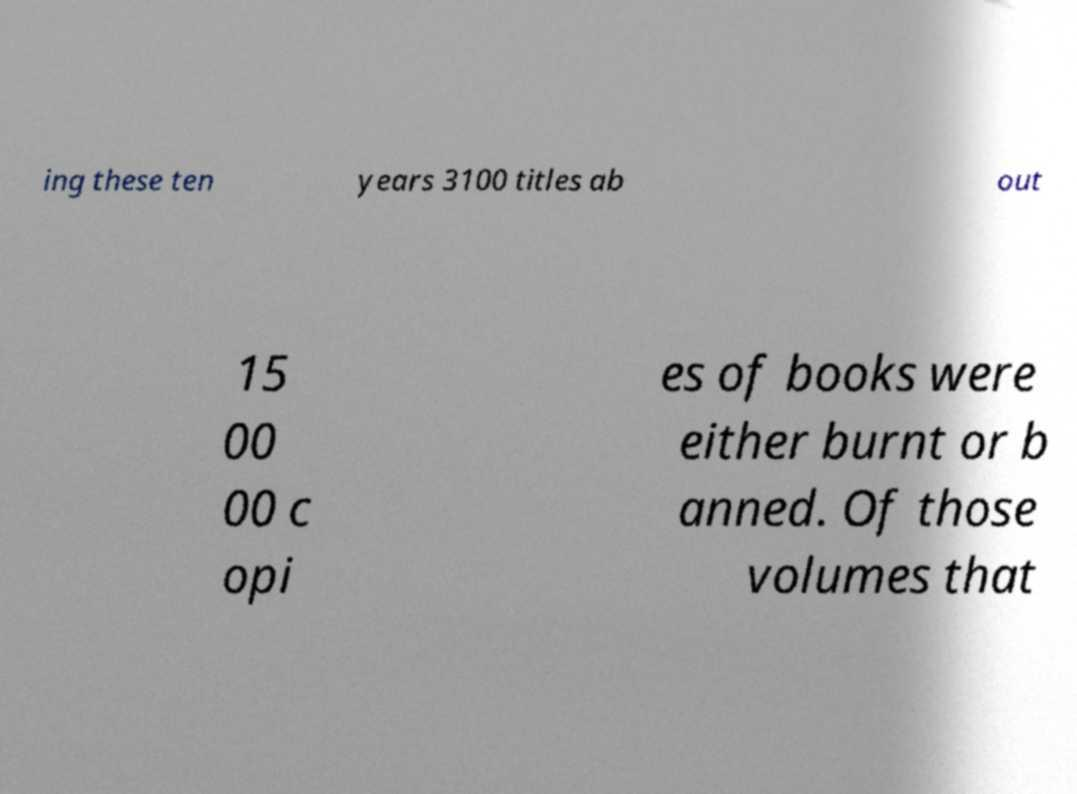Could you assist in decoding the text presented in this image and type it out clearly? ing these ten years 3100 titles ab out 15 00 00 c opi es of books were either burnt or b anned. Of those volumes that 